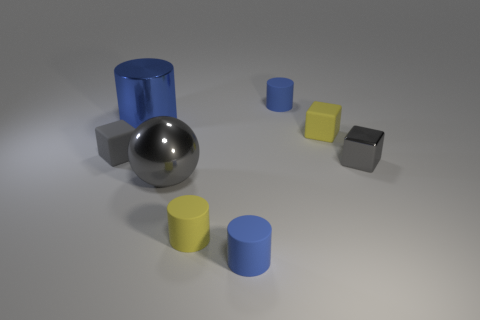Subtract all yellow spheres. How many blue cylinders are left? 3 Subtract all yellow cylinders. How many cylinders are left? 3 Subtract all yellow matte cylinders. How many cylinders are left? 3 Add 2 tiny blue shiny things. How many objects exist? 10 Subtract all brown cylinders. Subtract all red blocks. How many cylinders are left? 4 Subtract all cubes. How many objects are left? 5 Subtract all yellow metallic cubes. Subtract all tiny things. How many objects are left? 2 Add 1 blue cylinders. How many blue cylinders are left? 4 Add 7 small cubes. How many small cubes exist? 10 Subtract 0 cyan cylinders. How many objects are left? 8 